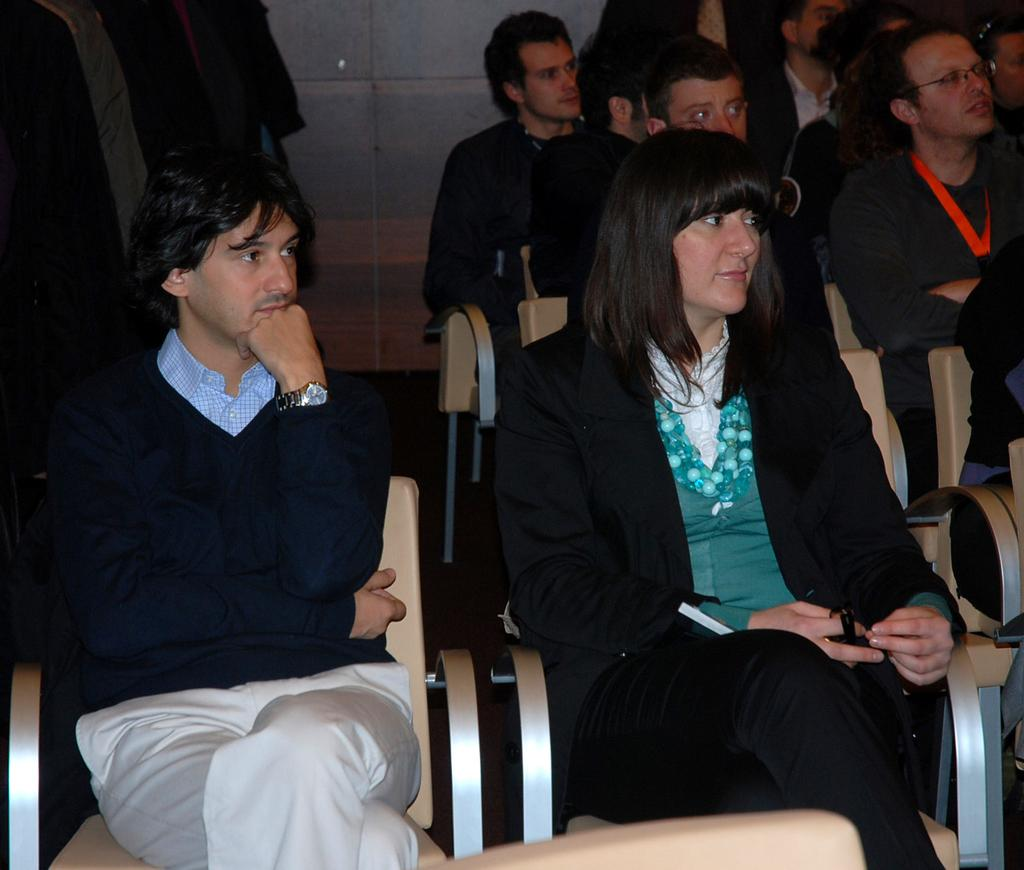What objects are on the floor in the image? There are chairs on the floor in the image. What are the people in the image doing? There is a group of people sitting on the chairs. What can be seen in the background of the image? There is a wall visible in the background of the image. What type of wealth is displayed by the people in the image? There is no indication of wealth in the image; it simply shows a group of people sitting on chairs. What event are the people in the image attending? There is no specific event mentioned or depicted in the image; it only shows a group of people sitting on chairs. 